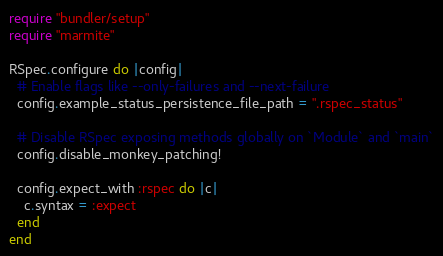<code> <loc_0><loc_0><loc_500><loc_500><_Ruby_>require "bundler/setup"
require "marmite"

RSpec.configure do |config|
  # Enable flags like --only-failures and --next-failure
  config.example_status_persistence_file_path = ".rspec_status"

  # Disable RSpec exposing methods globally on `Module` and `main`
  config.disable_monkey_patching!

  config.expect_with :rspec do |c|
    c.syntax = :expect
  end
end
</code> 